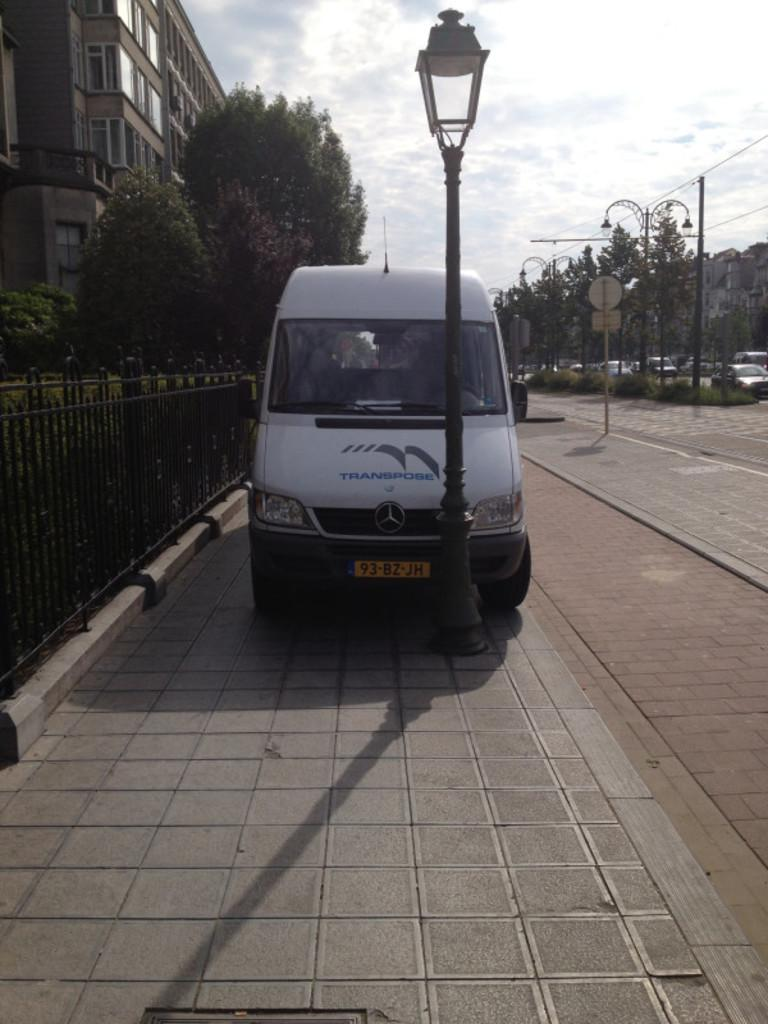<image>
Describe the image concisely. the number 93 that is on the front of a plate 